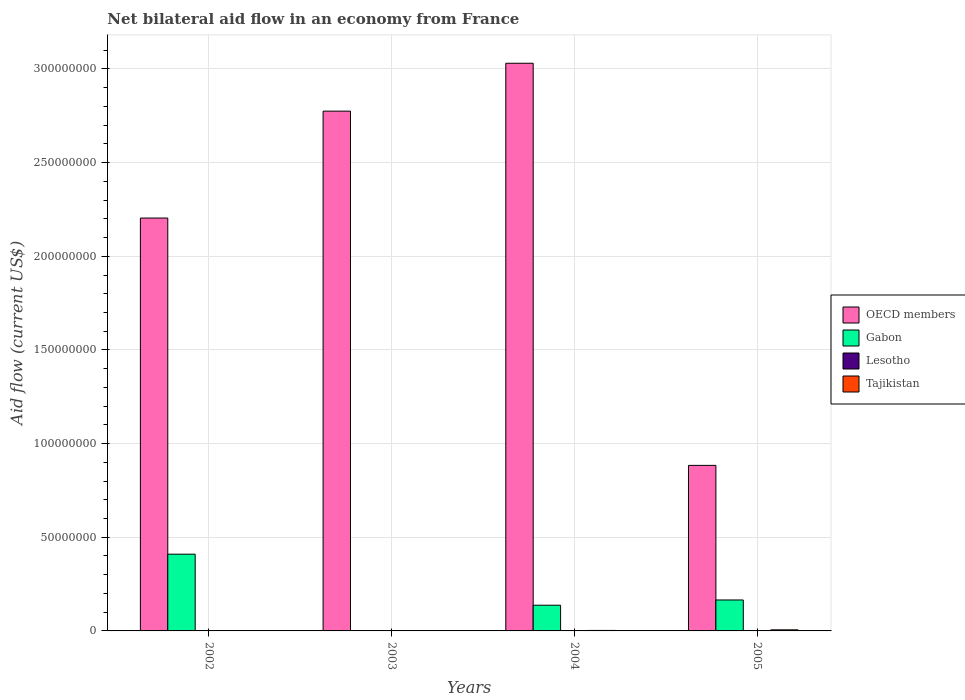Are the number of bars per tick equal to the number of legend labels?
Ensure brevity in your answer.  No. How many bars are there on the 4th tick from the left?
Give a very brief answer. 3. How many bars are there on the 4th tick from the right?
Give a very brief answer. 3. In how many cases, is the number of bars for a given year not equal to the number of legend labels?
Offer a terse response. 4. What is the net bilateral aid flow in Lesotho in 2005?
Make the answer very short. 0. Across all years, what is the maximum net bilateral aid flow in OECD members?
Your answer should be compact. 3.03e+08. What is the total net bilateral aid flow in Gabon in the graph?
Offer a terse response. 7.12e+07. What is the difference between the net bilateral aid flow in OECD members in 2003 and the net bilateral aid flow in Tajikistan in 2005?
Provide a succinct answer. 2.77e+08. In the year 2005, what is the difference between the net bilateral aid flow in Tajikistan and net bilateral aid flow in Gabon?
Make the answer very short. -1.59e+07. In how many years, is the net bilateral aid flow in Lesotho greater than 10000000 US$?
Make the answer very short. 0. What is the ratio of the net bilateral aid flow in Gabon in 2002 to that in 2004?
Offer a very short reply. 2.98. Is the difference between the net bilateral aid flow in Tajikistan in 2004 and 2005 greater than the difference between the net bilateral aid flow in Gabon in 2004 and 2005?
Your response must be concise. Yes. What is the difference between the highest and the second highest net bilateral aid flow in Gabon?
Your answer should be compact. 2.44e+07. What is the difference between the highest and the lowest net bilateral aid flow in OECD members?
Ensure brevity in your answer.  2.15e+08. Is the sum of the net bilateral aid flow in OECD members in 2002 and 2004 greater than the maximum net bilateral aid flow in Tajikistan across all years?
Provide a short and direct response. Yes. Is it the case that in every year, the sum of the net bilateral aid flow in Tajikistan and net bilateral aid flow in OECD members is greater than the net bilateral aid flow in Gabon?
Your response must be concise. Yes. How many bars are there?
Your answer should be compact. 11. How many years are there in the graph?
Keep it short and to the point. 4. What is the difference between two consecutive major ticks on the Y-axis?
Offer a terse response. 5.00e+07. How are the legend labels stacked?
Your response must be concise. Vertical. What is the title of the graph?
Your answer should be very brief. Net bilateral aid flow in an economy from France. What is the label or title of the Y-axis?
Your answer should be compact. Aid flow (current US$). What is the Aid flow (current US$) in OECD members in 2002?
Your response must be concise. 2.20e+08. What is the Aid flow (current US$) in Gabon in 2002?
Provide a short and direct response. 4.10e+07. What is the Aid flow (current US$) in OECD members in 2003?
Your answer should be compact. 2.78e+08. What is the Aid flow (current US$) in Tajikistan in 2003?
Offer a very short reply. 1.70e+05. What is the Aid flow (current US$) in OECD members in 2004?
Your answer should be compact. 3.03e+08. What is the Aid flow (current US$) in Gabon in 2004?
Make the answer very short. 1.37e+07. What is the Aid flow (current US$) of Lesotho in 2004?
Provide a short and direct response. 0. What is the Aid flow (current US$) in Tajikistan in 2004?
Offer a very short reply. 2.60e+05. What is the Aid flow (current US$) in OECD members in 2005?
Offer a terse response. 8.84e+07. What is the Aid flow (current US$) of Gabon in 2005?
Your answer should be compact. 1.65e+07. What is the Aid flow (current US$) of Tajikistan in 2005?
Your response must be concise. 5.80e+05. Across all years, what is the maximum Aid flow (current US$) in OECD members?
Offer a very short reply. 3.03e+08. Across all years, what is the maximum Aid flow (current US$) of Gabon?
Give a very brief answer. 4.10e+07. Across all years, what is the maximum Aid flow (current US$) in Tajikistan?
Offer a very short reply. 5.80e+05. Across all years, what is the minimum Aid flow (current US$) in OECD members?
Provide a short and direct response. 8.84e+07. Across all years, what is the minimum Aid flow (current US$) in Gabon?
Keep it short and to the point. 0. What is the total Aid flow (current US$) in OECD members in the graph?
Offer a terse response. 8.89e+08. What is the total Aid flow (current US$) of Gabon in the graph?
Make the answer very short. 7.12e+07. What is the total Aid flow (current US$) in Tajikistan in the graph?
Your answer should be compact. 1.22e+06. What is the difference between the Aid flow (current US$) in OECD members in 2002 and that in 2003?
Provide a short and direct response. -5.71e+07. What is the difference between the Aid flow (current US$) in OECD members in 2002 and that in 2004?
Your answer should be very brief. -8.26e+07. What is the difference between the Aid flow (current US$) in Gabon in 2002 and that in 2004?
Keep it short and to the point. 2.72e+07. What is the difference between the Aid flow (current US$) of OECD members in 2002 and that in 2005?
Give a very brief answer. 1.32e+08. What is the difference between the Aid flow (current US$) of Gabon in 2002 and that in 2005?
Your answer should be very brief. 2.44e+07. What is the difference between the Aid flow (current US$) of Tajikistan in 2002 and that in 2005?
Give a very brief answer. -3.70e+05. What is the difference between the Aid flow (current US$) of OECD members in 2003 and that in 2004?
Offer a terse response. -2.56e+07. What is the difference between the Aid flow (current US$) of Tajikistan in 2003 and that in 2004?
Provide a succinct answer. -9.00e+04. What is the difference between the Aid flow (current US$) of OECD members in 2003 and that in 2005?
Your answer should be very brief. 1.89e+08. What is the difference between the Aid flow (current US$) of Tajikistan in 2003 and that in 2005?
Ensure brevity in your answer.  -4.10e+05. What is the difference between the Aid flow (current US$) in OECD members in 2004 and that in 2005?
Give a very brief answer. 2.15e+08. What is the difference between the Aid flow (current US$) of Gabon in 2004 and that in 2005?
Keep it short and to the point. -2.79e+06. What is the difference between the Aid flow (current US$) of Tajikistan in 2004 and that in 2005?
Keep it short and to the point. -3.20e+05. What is the difference between the Aid flow (current US$) in OECD members in 2002 and the Aid flow (current US$) in Tajikistan in 2003?
Provide a short and direct response. 2.20e+08. What is the difference between the Aid flow (current US$) in Gabon in 2002 and the Aid flow (current US$) in Tajikistan in 2003?
Your response must be concise. 4.08e+07. What is the difference between the Aid flow (current US$) of OECD members in 2002 and the Aid flow (current US$) of Gabon in 2004?
Offer a very short reply. 2.07e+08. What is the difference between the Aid flow (current US$) of OECD members in 2002 and the Aid flow (current US$) of Tajikistan in 2004?
Provide a short and direct response. 2.20e+08. What is the difference between the Aid flow (current US$) of Gabon in 2002 and the Aid flow (current US$) of Tajikistan in 2004?
Keep it short and to the point. 4.07e+07. What is the difference between the Aid flow (current US$) of OECD members in 2002 and the Aid flow (current US$) of Gabon in 2005?
Your answer should be compact. 2.04e+08. What is the difference between the Aid flow (current US$) of OECD members in 2002 and the Aid flow (current US$) of Tajikistan in 2005?
Your response must be concise. 2.20e+08. What is the difference between the Aid flow (current US$) in Gabon in 2002 and the Aid flow (current US$) in Tajikistan in 2005?
Your answer should be compact. 4.04e+07. What is the difference between the Aid flow (current US$) in OECD members in 2003 and the Aid flow (current US$) in Gabon in 2004?
Make the answer very short. 2.64e+08. What is the difference between the Aid flow (current US$) in OECD members in 2003 and the Aid flow (current US$) in Tajikistan in 2004?
Ensure brevity in your answer.  2.77e+08. What is the difference between the Aid flow (current US$) of OECD members in 2003 and the Aid flow (current US$) of Gabon in 2005?
Make the answer very short. 2.61e+08. What is the difference between the Aid flow (current US$) of OECD members in 2003 and the Aid flow (current US$) of Tajikistan in 2005?
Give a very brief answer. 2.77e+08. What is the difference between the Aid flow (current US$) of OECD members in 2004 and the Aid flow (current US$) of Gabon in 2005?
Your answer should be compact. 2.87e+08. What is the difference between the Aid flow (current US$) of OECD members in 2004 and the Aid flow (current US$) of Tajikistan in 2005?
Keep it short and to the point. 3.02e+08. What is the difference between the Aid flow (current US$) in Gabon in 2004 and the Aid flow (current US$) in Tajikistan in 2005?
Give a very brief answer. 1.32e+07. What is the average Aid flow (current US$) of OECD members per year?
Your answer should be very brief. 2.22e+08. What is the average Aid flow (current US$) in Gabon per year?
Offer a terse response. 1.78e+07. What is the average Aid flow (current US$) of Tajikistan per year?
Offer a terse response. 3.05e+05. In the year 2002, what is the difference between the Aid flow (current US$) in OECD members and Aid flow (current US$) in Gabon?
Offer a terse response. 1.79e+08. In the year 2002, what is the difference between the Aid flow (current US$) in OECD members and Aid flow (current US$) in Tajikistan?
Your answer should be compact. 2.20e+08. In the year 2002, what is the difference between the Aid flow (current US$) in Gabon and Aid flow (current US$) in Tajikistan?
Offer a terse response. 4.08e+07. In the year 2003, what is the difference between the Aid flow (current US$) in OECD members and Aid flow (current US$) in Tajikistan?
Offer a very short reply. 2.77e+08. In the year 2004, what is the difference between the Aid flow (current US$) in OECD members and Aid flow (current US$) in Gabon?
Your answer should be compact. 2.89e+08. In the year 2004, what is the difference between the Aid flow (current US$) of OECD members and Aid flow (current US$) of Tajikistan?
Provide a short and direct response. 3.03e+08. In the year 2004, what is the difference between the Aid flow (current US$) in Gabon and Aid flow (current US$) in Tajikistan?
Make the answer very short. 1.35e+07. In the year 2005, what is the difference between the Aid flow (current US$) in OECD members and Aid flow (current US$) in Gabon?
Offer a very short reply. 7.19e+07. In the year 2005, what is the difference between the Aid flow (current US$) in OECD members and Aid flow (current US$) in Tajikistan?
Provide a succinct answer. 8.78e+07. In the year 2005, what is the difference between the Aid flow (current US$) of Gabon and Aid flow (current US$) of Tajikistan?
Provide a short and direct response. 1.59e+07. What is the ratio of the Aid flow (current US$) in OECD members in 2002 to that in 2003?
Offer a terse response. 0.79. What is the ratio of the Aid flow (current US$) of Tajikistan in 2002 to that in 2003?
Keep it short and to the point. 1.24. What is the ratio of the Aid flow (current US$) in OECD members in 2002 to that in 2004?
Your answer should be very brief. 0.73. What is the ratio of the Aid flow (current US$) in Gabon in 2002 to that in 2004?
Provide a succinct answer. 2.98. What is the ratio of the Aid flow (current US$) of Tajikistan in 2002 to that in 2004?
Ensure brevity in your answer.  0.81. What is the ratio of the Aid flow (current US$) in OECD members in 2002 to that in 2005?
Your response must be concise. 2.49. What is the ratio of the Aid flow (current US$) of Gabon in 2002 to that in 2005?
Make the answer very short. 2.48. What is the ratio of the Aid flow (current US$) of Tajikistan in 2002 to that in 2005?
Keep it short and to the point. 0.36. What is the ratio of the Aid flow (current US$) of OECD members in 2003 to that in 2004?
Provide a succinct answer. 0.92. What is the ratio of the Aid flow (current US$) of Tajikistan in 2003 to that in 2004?
Make the answer very short. 0.65. What is the ratio of the Aid flow (current US$) of OECD members in 2003 to that in 2005?
Your answer should be very brief. 3.14. What is the ratio of the Aid flow (current US$) in Tajikistan in 2003 to that in 2005?
Your answer should be very brief. 0.29. What is the ratio of the Aid flow (current US$) of OECD members in 2004 to that in 2005?
Ensure brevity in your answer.  3.43. What is the ratio of the Aid flow (current US$) of Gabon in 2004 to that in 2005?
Your response must be concise. 0.83. What is the ratio of the Aid flow (current US$) in Tajikistan in 2004 to that in 2005?
Provide a short and direct response. 0.45. What is the difference between the highest and the second highest Aid flow (current US$) of OECD members?
Your answer should be very brief. 2.56e+07. What is the difference between the highest and the second highest Aid flow (current US$) of Gabon?
Provide a short and direct response. 2.44e+07. What is the difference between the highest and the lowest Aid flow (current US$) of OECD members?
Offer a very short reply. 2.15e+08. What is the difference between the highest and the lowest Aid flow (current US$) of Gabon?
Your answer should be compact. 4.10e+07. 